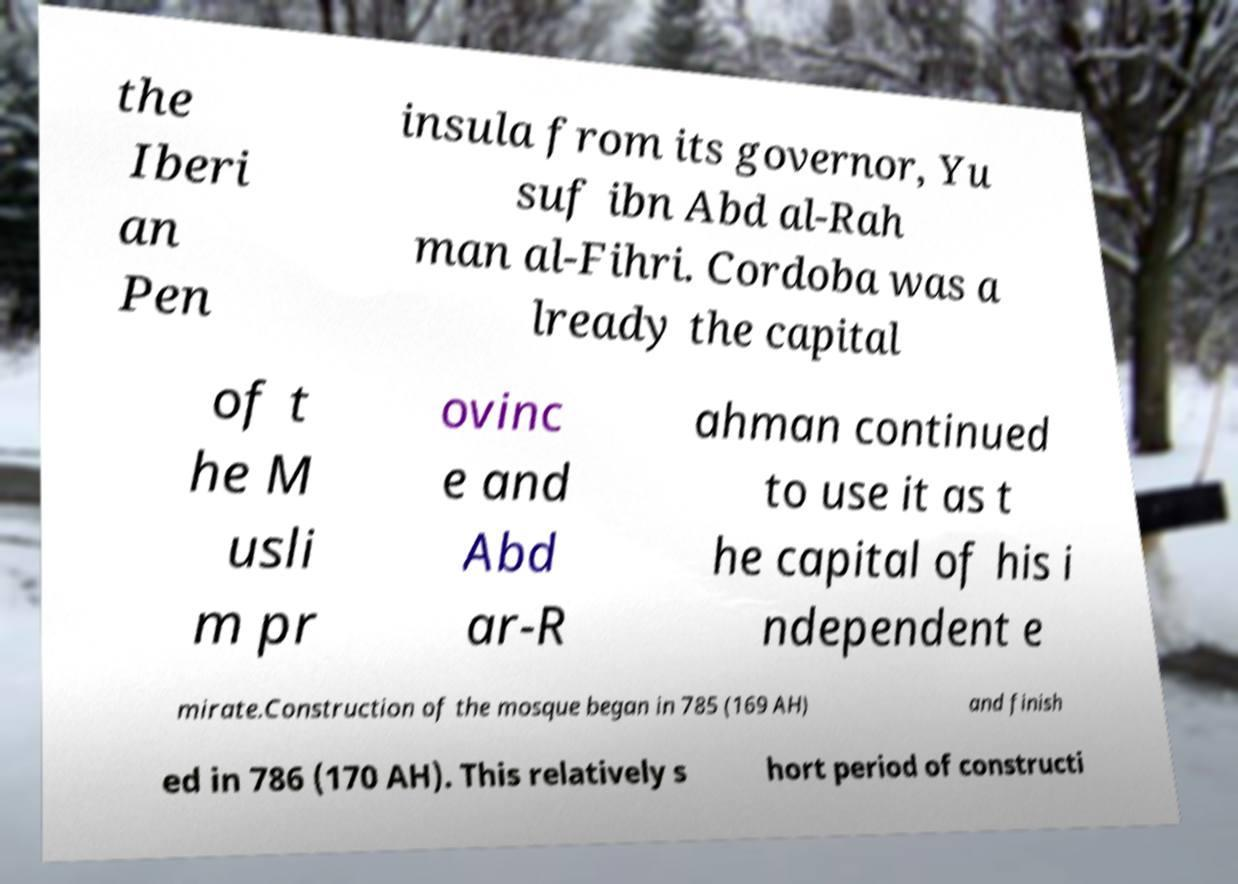Could you extract and type out the text from this image? the Iberi an Pen insula from its governor, Yu suf ibn Abd al-Rah man al-Fihri. Cordoba was a lready the capital of t he M usli m pr ovinc e and Abd ar-R ahman continued to use it as t he capital of his i ndependent e mirate.Construction of the mosque began in 785 (169 AH) and finish ed in 786 (170 AH). This relatively s hort period of constructi 